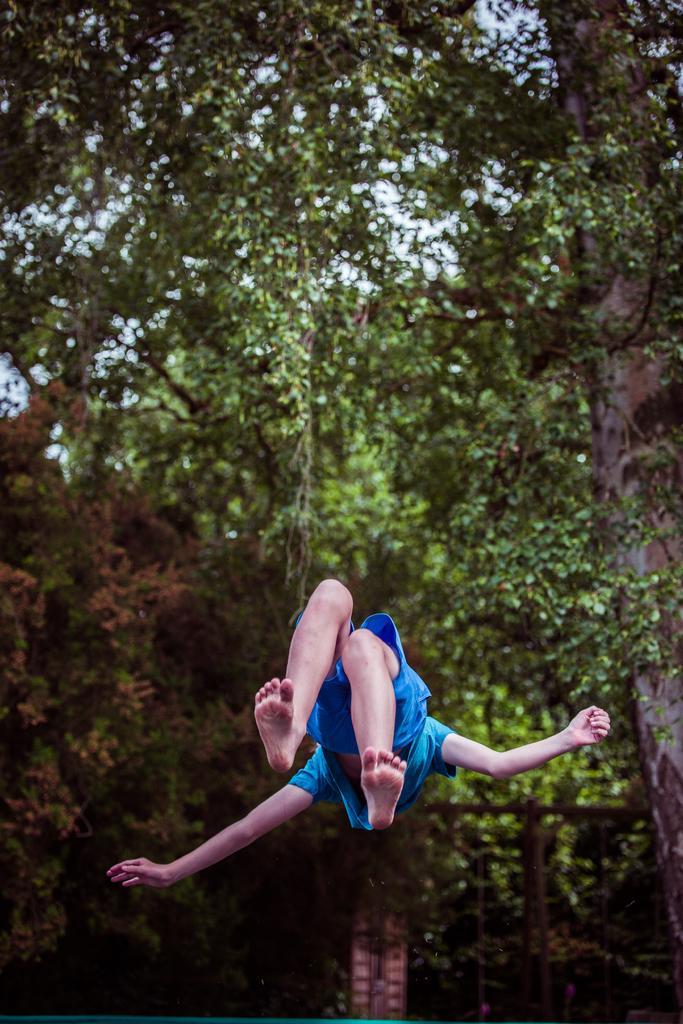Can you describe this image briefly? In the picture we can see a person under the person we can see the water surface and behind it we can see the trees. 